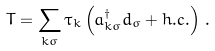Convert formula to latex. <formula><loc_0><loc_0><loc_500><loc_500>T = \sum _ { k \sigma } \tau _ { k } \left ( a _ { k \sigma } ^ { \dagger } d _ { \sigma } + h . c . \right ) \, .</formula> 